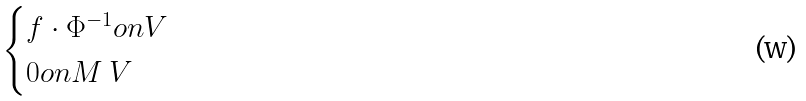<formula> <loc_0><loc_0><loc_500><loc_500>\begin{cases} f \cdot \Phi ^ { - 1 } o n V \\ 0 o n M \ V \end{cases}</formula> 